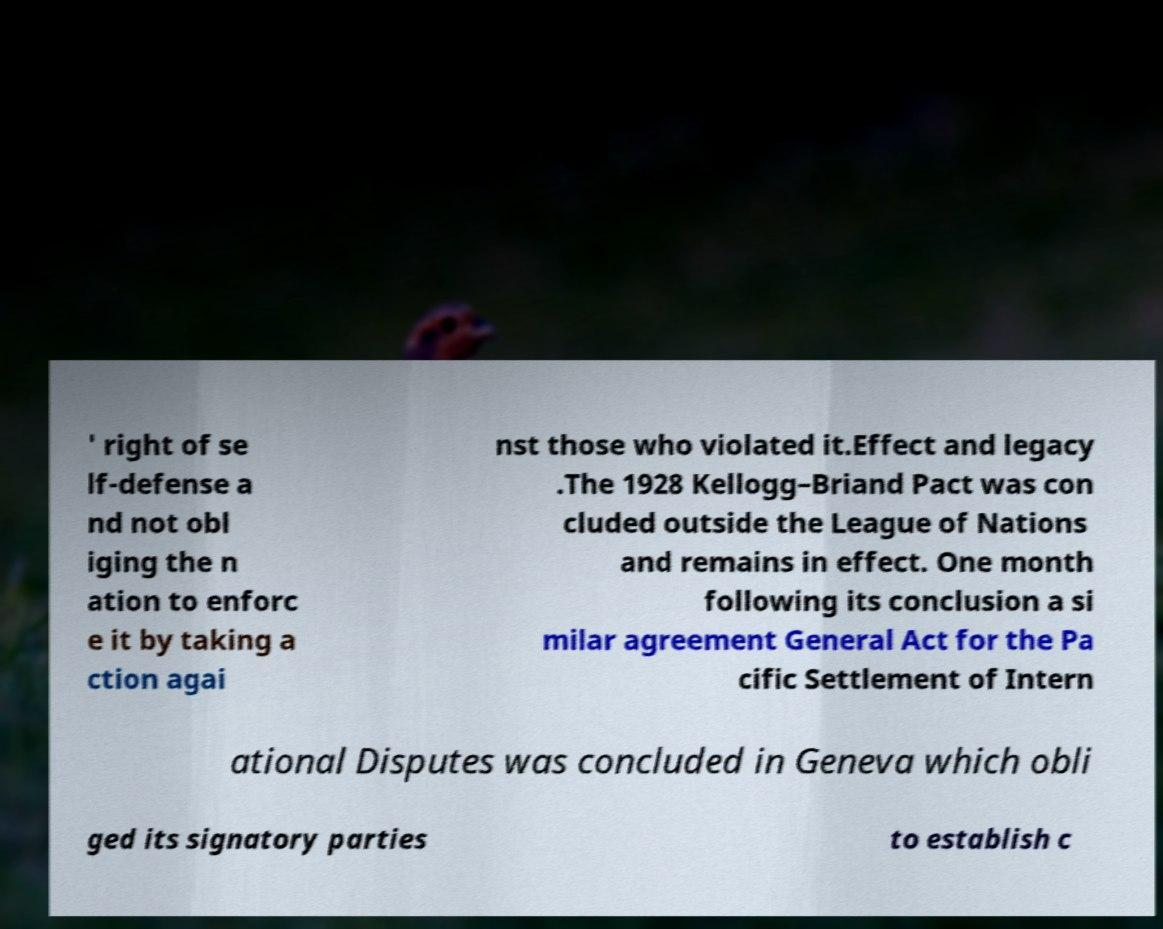Please identify and transcribe the text found in this image. ' right of se lf-defense a nd not obl iging the n ation to enforc e it by taking a ction agai nst those who violated it.Effect and legacy .The 1928 Kellogg–Briand Pact was con cluded outside the League of Nations and remains in effect. One month following its conclusion a si milar agreement General Act for the Pa cific Settlement of Intern ational Disputes was concluded in Geneva which obli ged its signatory parties to establish c 